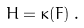Convert formula to latex. <formula><loc_0><loc_0><loc_500><loc_500>H = \kappa ( F ) \, .</formula> 